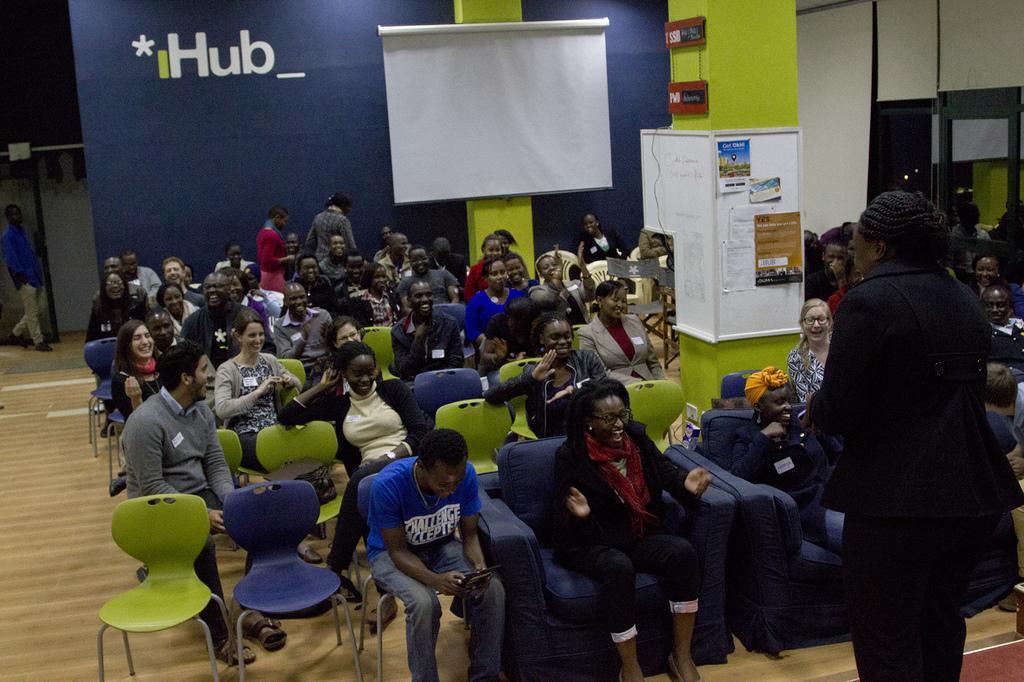Can you describe this image briefly? In this picture I can see there are some people sitting in the chairs, on the right there is a person standing and in the background I can see there is a blue wall and white screen. 